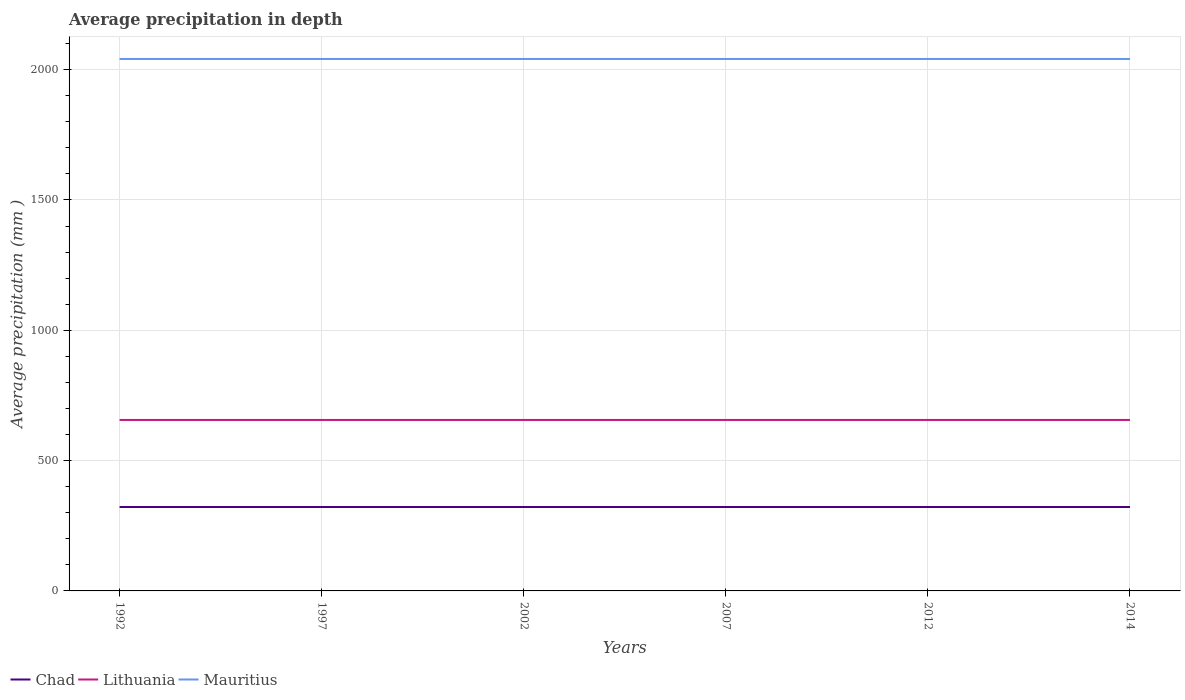Is the number of lines equal to the number of legend labels?
Your answer should be very brief. Yes. Across all years, what is the maximum average precipitation in Chad?
Ensure brevity in your answer.  322. What is the total average precipitation in Chad in the graph?
Ensure brevity in your answer.  0. Is the average precipitation in Chad strictly greater than the average precipitation in Mauritius over the years?
Provide a succinct answer. Yes. Are the values on the major ticks of Y-axis written in scientific E-notation?
Give a very brief answer. No. Does the graph contain grids?
Give a very brief answer. Yes. What is the title of the graph?
Ensure brevity in your answer.  Average precipitation in depth. What is the label or title of the Y-axis?
Your answer should be compact. Average precipitation (mm ). What is the Average precipitation (mm ) in Chad in 1992?
Your answer should be compact. 322. What is the Average precipitation (mm ) in Lithuania in 1992?
Your answer should be compact. 656. What is the Average precipitation (mm ) of Mauritius in 1992?
Provide a succinct answer. 2041. What is the Average precipitation (mm ) in Chad in 1997?
Your response must be concise. 322. What is the Average precipitation (mm ) of Lithuania in 1997?
Provide a short and direct response. 656. What is the Average precipitation (mm ) of Mauritius in 1997?
Offer a terse response. 2041. What is the Average precipitation (mm ) of Chad in 2002?
Provide a succinct answer. 322. What is the Average precipitation (mm ) in Lithuania in 2002?
Make the answer very short. 656. What is the Average precipitation (mm ) of Mauritius in 2002?
Provide a short and direct response. 2041. What is the Average precipitation (mm ) in Chad in 2007?
Provide a short and direct response. 322. What is the Average precipitation (mm ) of Lithuania in 2007?
Offer a terse response. 656. What is the Average precipitation (mm ) of Mauritius in 2007?
Offer a very short reply. 2041. What is the Average precipitation (mm ) of Chad in 2012?
Provide a short and direct response. 322. What is the Average precipitation (mm ) of Lithuania in 2012?
Make the answer very short. 656. What is the Average precipitation (mm ) in Mauritius in 2012?
Keep it short and to the point. 2041. What is the Average precipitation (mm ) of Chad in 2014?
Offer a terse response. 322. What is the Average precipitation (mm ) of Lithuania in 2014?
Your answer should be compact. 656. What is the Average precipitation (mm ) of Mauritius in 2014?
Provide a succinct answer. 2041. Across all years, what is the maximum Average precipitation (mm ) in Chad?
Offer a terse response. 322. Across all years, what is the maximum Average precipitation (mm ) in Lithuania?
Provide a succinct answer. 656. Across all years, what is the maximum Average precipitation (mm ) of Mauritius?
Give a very brief answer. 2041. Across all years, what is the minimum Average precipitation (mm ) of Chad?
Your answer should be very brief. 322. Across all years, what is the minimum Average precipitation (mm ) in Lithuania?
Give a very brief answer. 656. Across all years, what is the minimum Average precipitation (mm ) in Mauritius?
Your answer should be very brief. 2041. What is the total Average precipitation (mm ) in Chad in the graph?
Your answer should be very brief. 1932. What is the total Average precipitation (mm ) of Lithuania in the graph?
Offer a terse response. 3936. What is the total Average precipitation (mm ) in Mauritius in the graph?
Give a very brief answer. 1.22e+04. What is the difference between the Average precipitation (mm ) in Lithuania in 1992 and that in 2002?
Give a very brief answer. 0. What is the difference between the Average precipitation (mm ) in Chad in 1992 and that in 2007?
Your response must be concise. 0. What is the difference between the Average precipitation (mm ) of Lithuania in 1992 and that in 2007?
Offer a very short reply. 0. What is the difference between the Average precipitation (mm ) of Mauritius in 1992 and that in 2007?
Provide a short and direct response. 0. What is the difference between the Average precipitation (mm ) of Lithuania in 1992 and that in 2012?
Give a very brief answer. 0. What is the difference between the Average precipitation (mm ) in Mauritius in 1992 and that in 2014?
Keep it short and to the point. 0. What is the difference between the Average precipitation (mm ) in Lithuania in 1997 and that in 2002?
Keep it short and to the point. 0. What is the difference between the Average precipitation (mm ) of Lithuania in 1997 and that in 2007?
Ensure brevity in your answer.  0. What is the difference between the Average precipitation (mm ) of Mauritius in 1997 and that in 2007?
Your answer should be compact. 0. What is the difference between the Average precipitation (mm ) of Lithuania in 1997 and that in 2012?
Your answer should be compact. 0. What is the difference between the Average precipitation (mm ) of Chad in 1997 and that in 2014?
Give a very brief answer. 0. What is the difference between the Average precipitation (mm ) of Lithuania in 1997 and that in 2014?
Ensure brevity in your answer.  0. What is the difference between the Average precipitation (mm ) in Chad in 2002 and that in 2007?
Your response must be concise. 0. What is the difference between the Average precipitation (mm ) in Mauritius in 2002 and that in 2007?
Give a very brief answer. 0. What is the difference between the Average precipitation (mm ) in Lithuania in 2002 and that in 2014?
Provide a short and direct response. 0. What is the difference between the Average precipitation (mm ) in Mauritius in 2002 and that in 2014?
Your response must be concise. 0. What is the difference between the Average precipitation (mm ) in Lithuania in 2007 and that in 2012?
Provide a succinct answer. 0. What is the difference between the Average precipitation (mm ) in Chad in 2007 and that in 2014?
Your answer should be compact. 0. What is the difference between the Average precipitation (mm ) of Lithuania in 2007 and that in 2014?
Ensure brevity in your answer.  0. What is the difference between the Average precipitation (mm ) of Chad in 2012 and that in 2014?
Provide a succinct answer. 0. What is the difference between the Average precipitation (mm ) in Chad in 1992 and the Average precipitation (mm ) in Lithuania in 1997?
Your answer should be very brief. -334. What is the difference between the Average precipitation (mm ) in Chad in 1992 and the Average precipitation (mm ) in Mauritius in 1997?
Provide a short and direct response. -1719. What is the difference between the Average precipitation (mm ) of Lithuania in 1992 and the Average precipitation (mm ) of Mauritius in 1997?
Ensure brevity in your answer.  -1385. What is the difference between the Average precipitation (mm ) in Chad in 1992 and the Average precipitation (mm ) in Lithuania in 2002?
Offer a very short reply. -334. What is the difference between the Average precipitation (mm ) of Chad in 1992 and the Average precipitation (mm ) of Mauritius in 2002?
Keep it short and to the point. -1719. What is the difference between the Average precipitation (mm ) in Lithuania in 1992 and the Average precipitation (mm ) in Mauritius in 2002?
Your response must be concise. -1385. What is the difference between the Average precipitation (mm ) in Chad in 1992 and the Average precipitation (mm ) in Lithuania in 2007?
Keep it short and to the point. -334. What is the difference between the Average precipitation (mm ) of Chad in 1992 and the Average precipitation (mm ) of Mauritius in 2007?
Ensure brevity in your answer.  -1719. What is the difference between the Average precipitation (mm ) in Lithuania in 1992 and the Average precipitation (mm ) in Mauritius in 2007?
Make the answer very short. -1385. What is the difference between the Average precipitation (mm ) of Chad in 1992 and the Average precipitation (mm ) of Lithuania in 2012?
Your answer should be very brief. -334. What is the difference between the Average precipitation (mm ) of Chad in 1992 and the Average precipitation (mm ) of Mauritius in 2012?
Give a very brief answer. -1719. What is the difference between the Average precipitation (mm ) of Lithuania in 1992 and the Average precipitation (mm ) of Mauritius in 2012?
Your answer should be compact. -1385. What is the difference between the Average precipitation (mm ) of Chad in 1992 and the Average precipitation (mm ) of Lithuania in 2014?
Offer a very short reply. -334. What is the difference between the Average precipitation (mm ) in Chad in 1992 and the Average precipitation (mm ) in Mauritius in 2014?
Ensure brevity in your answer.  -1719. What is the difference between the Average precipitation (mm ) of Lithuania in 1992 and the Average precipitation (mm ) of Mauritius in 2014?
Make the answer very short. -1385. What is the difference between the Average precipitation (mm ) in Chad in 1997 and the Average precipitation (mm ) in Lithuania in 2002?
Provide a succinct answer. -334. What is the difference between the Average precipitation (mm ) of Chad in 1997 and the Average precipitation (mm ) of Mauritius in 2002?
Your answer should be compact. -1719. What is the difference between the Average precipitation (mm ) of Lithuania in 1997 and the Average precipitation (mm ) of Mauritius in 2002?
Provide a succinct answer. -1385. What is the difference between the Average precipitation (mm ) of Chad in 1997 and the Average precipitation (mm ) of Lithuania in 2007?
Provide a succinct answer. -334. What is the difference between the Average precipitation (mm ) of Chad in 1997 and the Average precipitation (mm ) of Mauritius in 2007?
Give a very brief answer. -1719. What is the difference between the Average precipitation (mm ) of Lithuania in 1997 and the Average precipitation (mm ) of Mauritius in 2007?
Your response must be concise. -1385. What is the difference between the Average precipitation (mm ) in Chad in 1997 and the Average precipitation (mm ) in Lithuania in 2012?
Your answer should be very brief. -334. What is the difference between the Average precipitation (mm ) in Chad in 1997 and the Average precipitation (mm ) in Mauritius in 2012?
Make the answer very short. -1719. What is the difference between the Average precipitation (mm ) of Lithuania in 1997 and the Average precipitation (mm ) of Mauritius in 2012?
Provide a succinct answer. -1385. What is the difference between the Average precipitation (mm ) in Chad in 1997 and the Average precipitation (mm ) in Lithuania in 2014?
Your response must be concise. -334. What is the difference between the Average precipitation (mm ) in Chad in 1997 and the Average precipitation (mm ) in Mauritius in 2014?
Keep it short and to the point. -1719. What is the difference between the Average precipitation (mm ) of Lithuania in 1997 and the Average precipitation (mm ) of Mauritius in 2014?
Make the answer very short. -1385. What is the difference between the Average precipitation (mm ) of Chad in 2002 and the Average precipitation (mm ) of Lithuania in 2007?
Keep it short and to the point. -334. What is the difference between the Average precipitation (mm ) in Chad in 2002 and the Average precipitation (mm ) in Mauritius in 2007?
Provide a succinct answer. -1719. What is the difference between the Average precipitation (mm ) of Lithuania in 2002 and the Average precipitation (mm ) of Mauritius in 2007?
Ensure brevity in your answer.  -1385. What is the difference between the Average precipitation (mm ) in Chad in 2002 and the Average precipitation (mm ) in Lithuania in 2012?
Your answer should be compact. -334. What is the difference between the Average precipitation (mm ) of Chad in 2002 and the Average precipitation (mm ) of Mauritius in 2012?
Offer a terse response. -1719. What is the difference between the Average precipitation (mm ) in Lithuania in 2002 and the Average precipitation (mm ) in Mauritius in 2012?
Ensure brevity in your answer.  -1385. What is the difference between the Average precipitation (mm ) of Chad in 2002 and the Average precipitation (mm ) of Lithuania in 2014?
Your answer should be compact. -334. What is the difference between the Average precipitation (mm ) of Chad in 2002 and the Average precipitation (mm ) of Mauritius in 2014?
Ensure brevity in your answer.  -1719. What is the difference between the Average precipitation (mm ) in Lithuania in 2002 and the Average precipitation (mm ) in Mauritius in 2014?
Ensure brevity in your answer.  -1385. What is the difference between the Average precipitation (mm ) of Chad in 2007 and the Average precipitation (mm ) of Lithuania in 2012?
Your answer should be very brief. -334. What is the difference between the Average precipitation (mm ) of Chad in 2007 and the Average precipitation (mm ) of Mauritius in 2012?
Your answer should be very brief. -1719. What is the difference between the Average precipitation (mm ) of Lithuania in 2007 and the Average precipitation (mm ) of Mauritius in 2012?
Make the answer very short. -1385. What is the difference between the Average precipitation (mm ) in Chad in 2007 and the Average precipitation (mm ) in Lithuania in 2014?
Offer a terse response. -334. What is the difference between the Average precipitation (mm ) of Chad in 2007 and the Average precipitation (mm ) of Mauritius in 2014?
Your response must be concise. -1719. What is the difference between the Average precipitation (mm ) of Lithuania in 2007 and the Average precipitation (mm ) of Mauritius in 2014?
Your response must be concise. -1385. What is the difference between the Average precipitation (mm ) in Chad in 2012 and the Average precipitation (mm ) in Lithuania in 2014?
Ensure brevity in your answer.  -334. What is the difference between the Average precipitation (mm ) in Chad in 2012 and the Average precipitation (mm ) in Mauritius in 2014?
Provide a succinct answer. -1719. What is the difference between the Average precipitation (mm ) in Lithuania in 2012 and the Average precipitation (mm ) in Mauritius in 2014?
Provide a short and direct response. -1385. What is the average Average precipitation (mm ) of Chad per year?
Your answer should be very brief. 322. What is the average Average precipitation (mm ) of Lithuania per year?
Provide a short and direct response. 656. What is the average Average precipitation (mm ) in Mauritius per year?
Make the answer very short. 2041. In the year 1992, what is the difference between the Average precipitation (mm ) of Chad and Average precipitation (mm ) of Lithuania?
Your answer should be very brief. -334. In the year 1992, what is the difference between the Average precipitation (mm ) in Chad and Average precipitation (mm ) in Mauritius?
Ensure brevity in your answer.  -1719. In the year 1992, what is the difference between the Average precipitation (mm ) in Lithuania and Average precipitation (mm ) in Mauritius?
Provide a succinct answer. -1385. In the year 1997, what is the difference between the Average precipitation (mm ) in Chad and Average precipitation (mm ) in Lithuania?
Offer a terse response. -334. In the year 1997, what is the difference between the Average precipitation (mm ) in Chad and Average precipitation (mm ) in Mauritius?
Your answer should be very brief. -1719. In the year 1997, what is the difference between the Average precipitation (mm ) of Lithuania and Average precipitation (mm ) of Mauritius?
Your response must be concise. -1385. In the year 2002, what is the difference between the Average precipitation (mm ) of Chad and Average precipitation (mm ) of Lithuania?
Your answer should be very brief. -334. In the year 2002, what is the difference between the Average precipitation (mm ) in Chad and Average precipitation (mm ) in Mauritius?
Give a very brief answer. -1719. In the year 2002, what is the difference between the Average precipitation (mm ) of Lithuania and Average precipitation (mm ) of Mauritius?
Make the answer very short. -1385. In the year 2007, what is the difference between the Average precipitation (mm ) in Chad and Average precipitation (mm ) in Lithuania?
Your answer should be compact. -334. In the year 2007, what is the difference between the Average precipitation (mm ) in Chad and Average precipitation (mm ) in Mauritius?
Provide a short and direct response. -1719. In the year 2007, what is the difference between the Average precipitation (mm ) in Lithuania and Average precipitation (mm ) in Mauritius?
Offer a very short reply. -1385. In the year 2012, what is the difference between the Average precipitation (mm ) in Chad and Average precipitation (mm ) in Lithuania?
Offer a very short reply. -334. In the year 2012, what is the difference between the Average precipitation (mm ) in Chad and Average precipitation (mm ) in Mauritius?
Offer a very short reply. -1719. In the year 2012, what is the difference between the Average precipitation (mm ) of Lithuania and Average precipitation (mm ) of Mauritius?
Provide a succinct answer. -1385. In the year 2014, what is the difference between the Average precipitation (mm ) in Chad and Average precipitation (mm ) in Lithuania?
Make the answer very short. -334. In the year 2014, what is the difference between the Average precipitation (mm ) of Chad and Average precipitation (mm ) of Mauritius?
Give a very brief answer. -1719. In the year 2014, what is the difference between the Average precipitation (mm ) in Lithuania and Average precipitation (mm ) in Mauritius?
Your answer should be very brief. -1385. What is the ratio of the Average precipitation (mm ) of Chad in 1992 to that in 2002?
Offer a very short reply. 1. What is the ratio of the Average precipitation (mm ) of Lithuania in 1992 to that in 2002?
Provide a short and direct response. 1. What is the ratio of the Average precipitation (mm ) in Mauritius in 1992 to that in 2002?
Keep it short and to the point. 1. What is the ratio of the Average precipitation (mm ) of Chad in 1992 to that in 2007?
Provide a short and direct response. 1. What is the ratio of the Average precipitation (mm ) of Lithuania in 1992 to that in 2007?
Your answer should be compact. 1. What is the ratio of the Average precipitation (mm ) in Mauritius in 1992 to that in 2007?
Provide a short and direct response. 1. What is the ratio of the Average precipitation (mm ) of Lithuania in 1992 to that in 2012?
Your answer should be compact. 1. What is the ratio of the Average precipitation (mm ) of Mauritius in 1992 to that in 2012?
Give a very brief answer. 1. What is the ratio of the Average precipitation (mm ) in Lithuania in 1992 to that in 2014?
Offer a very short reply. 1. What is the ratio of the Average precipitation (mm ) of Lithuania in 1997 to that in 2002?
Give a very brief answer. 1. What is the ratio of the Average precipitation (mm ) in Mauritius in 1997 to that in 2002?
Your answer should be compact. 1. What is the ratio of the Average precipitation (mm ) in Lithuania in 1997 to that in 2007?
Give a very brief answer. 1. What is the ratio of the Average precipitation (mm ) of Mauritius in 1997 to that in 2007?
Give a very brief answer. 1. What is the ratio of the Average precipitation (mm ) in Chad in 2002 to that in 2007?
Your answer should be compact. 1. What is the ratio of the Average precipitation (mm ) in Lithuania in 2002 to that in 2007?
Offer a very short reply. 1. What is the ratio of the Average precipitation (mm ) of Mauritius in 2002 to that in 2007?
Ensure brevity in your answer.  1. What is the ratio of the Average precipitation (mm ) of Chad in 2002 to that in 2012?
Your answer should be compact. 1. What is the ratio of the Average precipitation (mm ) of Chad in 2002 to that in 2014?
Your answer should be very brief. 1. What is the ratio of the Average precipitation (mm ) of Lithuania in 2002 to that in 2014?
Give a very brief answer. 1. What is the ratio of the Average precipitation (mm ) in Mauritius in 2002 to that in 2014?
Keep it short and to the point. 1. What is the ratio of the Average precipitation (mm ) of Chad in 2007 to that in 2012?
Provide a succinct answer. 1. What is the ratio of the Average precipitation (mm ) of Lithuania in 2007 to that in 2012?
Offer a terse response. 1. What is the ratio of the Average precipitation (mm ) in Mauritius in 2007 to that in 2012?
Your answer should be compact. 1. What is the ratio of the Average precipitation (mm ) in Chad in 2007 to that in 2014?
Provide a short and direct response. 1. What is the ratio of the Average precipitation (mm ) of Chad in 2012 to that in 2014?
Offer a terse response. 1. What is the difference between the highest and the second highest Average precipitation (mm ) of Chad?
Your answer should be compact. 0. What is the difference between the highest and the lowest Average precipitation (mm ) of Lithuania?
Provide a succinct answer. 0. What is the difference between the highest and the lowest Average precipitation (mm ) in Mauritius?
Your response must be concise. 0. 